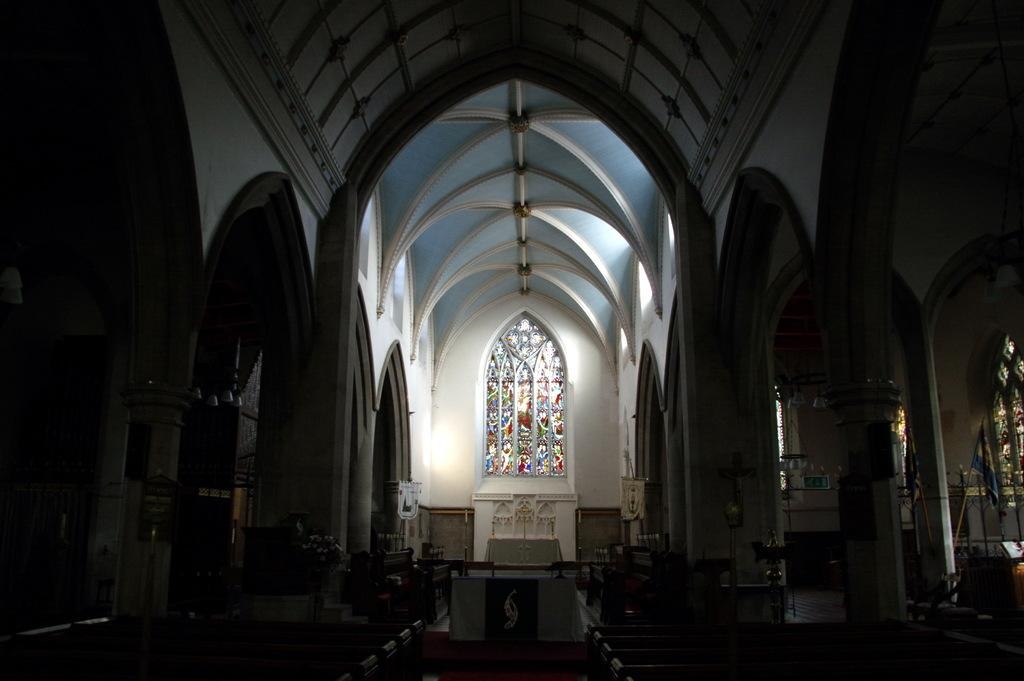What type of location is depicted in the image? The image is an inside view of a building. What type of furniture can be seen in the image? There are benches in the image. What can be found in the image besides furniture? There are objects, pillars, a flagpole, plants with flowers, objects on a table, designs on window glasses, and other objects in the image. What route does the rat take to reach the table in the image? There is no rat present in the image, so it is not possible to determine a route. 